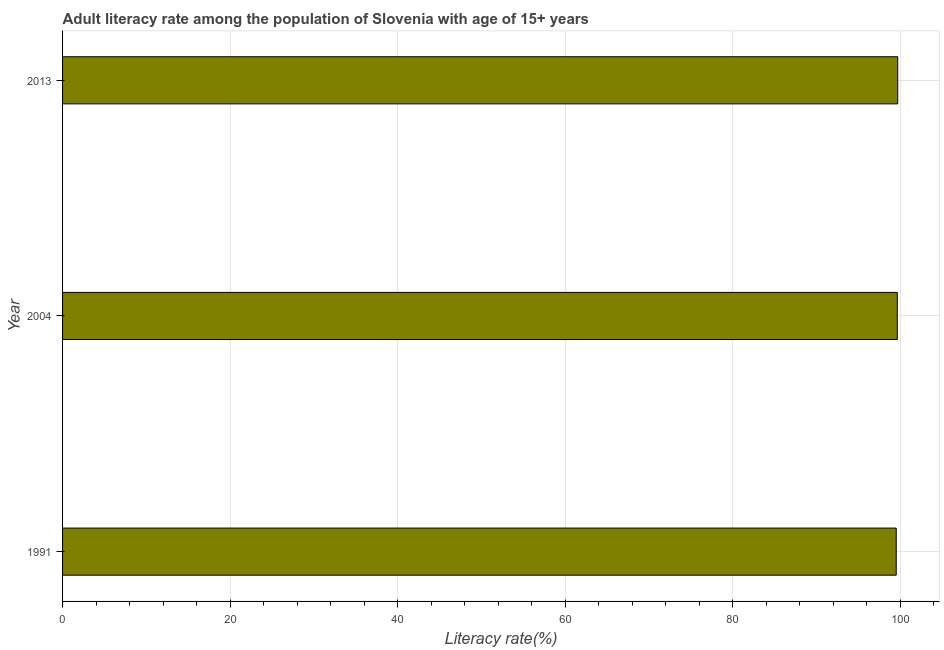Does the graph contain any zero values?
Keep it short and to the point. No. Does the graph contain grids?
Ensure brevity in your answer.  Yes. What is the title of the graph?
Ensure brevity in your answer.  Adult literacy rate among the population of Slovenia with age of 15+ years. What is the label or title of the X-axis?
Keep it short and to the point. Literacy rate(%). What is the label or title of the Y-axis?
Keep it short and to the point. Year. What is the adult literacy rate in 2004?
Your response must be concise. 99.65. Across all years, what is the maximum adult literacy rate?
Ensure brevity in your answer.  99.71. Across all years, what is the minimum adult literacy rate?
Keep it short and to the point. 99.52. In which year was the adult literacy rate minimum?
Provide a short and direct response. 1991. What is the sum of the adult literacy rate?
Your response must be concise. 298.88. What is the difference between the adult literacy rate in 1991 and 2013?
Your answer should be very brief. -0.18. What is the average adult literacy rate per year?
Your answer should be very brief. 99.63. What is the median adult literacy rate?
Offer a very short reply. 99.65. Do a majority of the years between 1991 and 2004 (inclusive) have adult literacy rate greater than 4 %?
Your response must be concise. Yes. What is the difference between the highest and the second highest adult literacy rate?
Ensure brevity in your answer.  0.05. What is the difference between the highest and the lowest adult literacy rate?
Offer a terse response. 0.18. In how many years, is the adult literacy rate greater than the average adult literacy rate taken over all years?
Make the answer very short. 2. Are all the bars in the graph horizontal?
Give a very brief answer. Yes. What is the Literacy rate(%) of 1991?
Your answer should be very brief. 99.52. What is the Literacy rate(%) of 2004?
Keep it short and to the point. 99.65. What is the Literacy rate(%) of 2013?
Your response must be concise. 99.71. What is the difference between the Literacy rate(%) in 1991 and 2004?
Your answer should be very brief. -0.13. What is the difference between the Literacy rate(%) in 1991 and 2013?
Your answer should be very brief. -0.18. What is the difference between the Literacy rate(%) in 2004 and 2013?
Provide a succinct answer. -0.05. What is the ratio of the Literacy rate(%) in 1991 to that in 2004?
Provide a succinct answer. 1. What is the ratio of the Literacy rate(%) in 2004 to that in 2013?
Offer a very short reply. 1. 